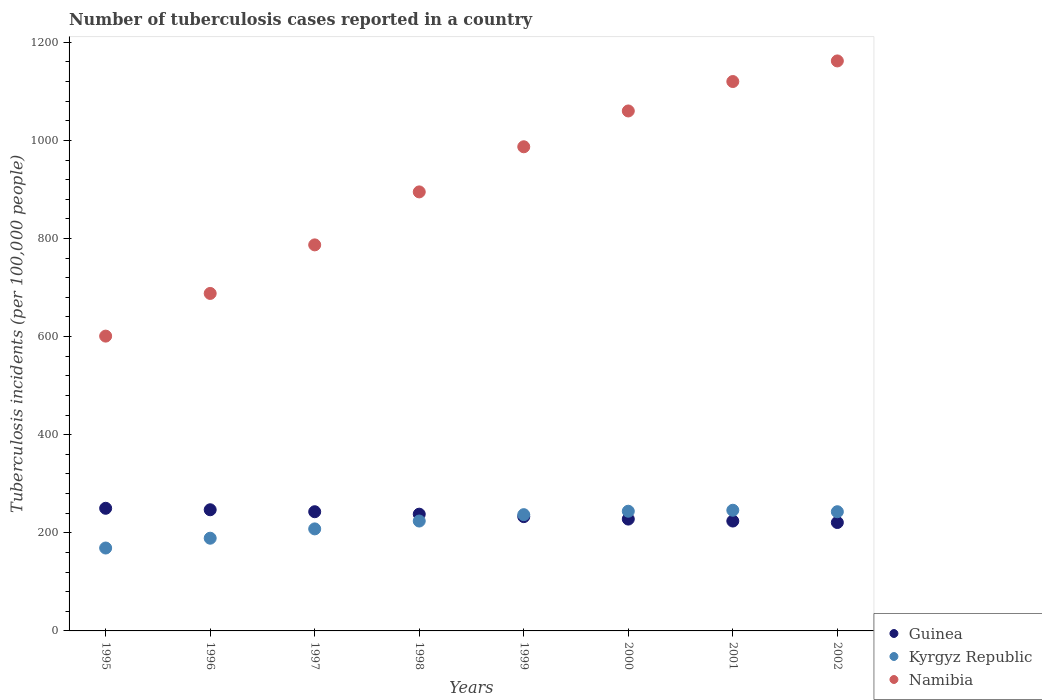How many different coloured dotlines are there?
Make the answer very short. 3. What is the number of tuberculosis cases reported in in Kyrgyz Republic in 2001?
Provide a short and direct response. 246. Across all years, what is the maximum number of tuberculosis cases reported in in Guinea?
Make the answer very short. 250. Across all years, what is the minimum number of tuberculosis cases reported in in Namibia?
Make the answer very short. 601. In which year was the number of tuberculosis cases reported in in Namibia maximum?
Offer a very short reply. 2002. In which year was the number of tuberculosis cases reported in in Namibia minimum?
Keep it short and to the point. 1995. What is the total number of tuberculosis cases reported in in Guinea in the graph?
Your response must be concise. 1884. What is the difference between the number of tuberculosis cases reported in in Namibia in 1997 and that in 2001?
Your answer should be very brief. -333. What is the difference between the number of tuberculosis cases reported in in Guinea in 1998 and the number of tuberculosis cases reported in in Namibia in 1999?
Your response must be concise. -749. What is the average number of tuberculosis cases reported in in Kyrgyz Republic per year?
Provide a short and direct response. 220. In the year 1997, what is the difference between the number of tuberculosis cases reported in in Kyrgyz Republic and number of tuberculosis cases reported in in Guinea?
Give a very brief answer. -35. What is the ratio of the number of tuberculosis cases reported in in Namibia in 2001 to that in 2002?
Your answer should be compact. 0.96. Is the difference between the number of tuberculosis cases reported in in Kyrgyz Republic in 1995 and 2002 greater than the difference between the number of tuberculosis cases reported in in Guinea in 1995 and 2002?
Your answer should be very brief. No. What is the difference between the highest and the lowest number of tuberculosis cases reported in in Kyrgyz Republic?
Provide a short and direct response. 77. In how many years, is the number of tuberculosis cases reported in in Namibia greater than the average number of tuberculosis cases reported in in Namibia taken over all years?
Provide a short and direct response. 4. Does the number of tuberculosis cases reported in in Namibia monotonically increase over the years?
Your response must be concise. Yes. Is the number of tuberculosis cases reported in in Kyrgyz Republic strictly greater than the number of tuberculosis cases reported in in Namibia over the years?
Your answer should be compact. No. How many years are there in the graph?
Provide a succinct answer. 8. What is the difference between two consecutive major ticks on the Y-axis?
Make the answer very short. 200. Are the values on the major ticks of Y-axis written in scientific E-notation?
Your answer should be compact. No. Does the graph contain any zero values?
Ensure brevity in your answer.  No. Where does the legend appear in the graph?
Give a very brief answer. Bottom right. How many legend labels are there?
Provide a short and direct response. 3. How are the legend labels stacked?
Your answer should be compact. Vertical. What is the title of the graph?
Offer a terse response. Number of tuberculosis cases reported in a country. Does "Saudi Arabia" appear as one of the legend labels in the graph?
Your answer should be compact. No. What is the label or title of the X-axis?
Make the answer very short. Years. What is the label or title of the Y-axis?
Keep it short and to the point. Tuberculosis incidents (per 100,0 people). What is the Tuberculosis incidents (per 100,000 people) of Guinea in 1995?
Offer a very short reply. 250. What is the Tuberculosis incidents (per 100,000 people) of Kyrgyz Republic in 1995?
Your answer should be compact. 169. What is the Tuberculosis incidents (per 100,000 people) of Namibia in 1995?
Your answer should be very brief. 601. What is the Tuberculosis incidents (per 100,000 people) of Guinea in 1996?
Keep it short and to the point. 247. What is the Tuberculosis incidents (per 100,000 people) of Kyrgyz Republic in 1996?
Give a very brief answer. 189. What is the Tuberculosis incidents (per 100,000 people) of Namibia in 1996?
Keep it short and to the point. 688. What is the Tuberculosis incidents (per 100,000 people) in Guinea in 1997?
Keep it short and to the point. 243. What is the Tuberculosis incidents (per 100,000 people) of Kyrgyz Republic in 1997?
Your response must be concise. 208. What is the Tuberculosis incidents (per 100,000 people) in Namibia in 1997?
Ensure brevity in your answer.  787. What is the Tuberculosis incidents (per 100,000 people) in Guinea in 1998?
Your response must be concise. 238. What is the Tuberculosis incidents (per 100,000 people) of Kyrgyz Republic in 1998?
Offer a very short reply. 224. What is the Tuberculosis incidents (per 100,000 people) in Namibia in 1998?
Ensure brevity in your answer.  895. What is the Tuberculosis incidents (per 100,000 people) of Guinea in 1999?
Ensure brevity in your answer.  233. What is the Tuberculosis incidents (per 100,000 people) of Kyrgyz Republic in 1999?
Offer a very short reply. 237. What is the Tuberculosis incidents (per 100,000 people) in Namibia in 1999?
Make the answer very short. 987. What is the Tuberculosis incidents (per 100,000 people) in Guinea in 2000?
Ensure brevity in your answer.  228. What is the Tuberculosis incidents (per 100,000 people) of Kyrgyz Republic in 2000?
Provide a succinct answer. 244. What is the Tuberculosis incidents (per 100,000 people) of Namibia in 2000?
Make the answer very short. 1060. What is the Tuberculosis incidents (per 100,000 people) of Guinea in 2001?
Offer a very short reply. 224. What is the Tuberculosis incidents (per 100,000 people) in Kyrgyz Republic in 2001?
Provide a succinct answer. 246. What is the Tuberculosis incidents (per 100,000 people) in Namibia in 2001?
Make the answer very short. 1120. What is the Tuberculosis incidents (per 100,000 people) in Guinea in 2002?
Your answer should be very brief. 221. What is the Tuberculosis incidents (per 100,000 people) in Kyrgyz Republic in 2002?
Your response must be concise. 243. What is the Tuberculosis incidents (per 100,000 people) in Namibia in 2002?
Give a very brief answer. 1162. Across all years, what is the maximum Tuberculosis incidents (per 100,000 people) in Guinea?
Offer a very short reply. 250. Across all years, what is the maximum Tuberculosis incidents (per 100,000 people) of Kyrgyz Republic?
Offer a very short reply. 246. Across all years, what is the maximum Tuberculosis incidents (per 100,000 people) in Namibia?
Ensure brevity in your answer.  1162. Across all years, what is the minimum Tuberculosis incidents (per 100,000 people) of Guinea?
Your answer should be very brief. 221. Across all years, what is the minimum Tuberculosis incidents (per 100,000 people) of Kyrgyz Republic?
Offer a very short reply. 169. Across all years, what is the minimum Tuberculosis incidents (per 100,000 people) of Namibia?
Provide a succinct answer. 601. What is the total Tuberculosis incidents (per 100,000 people) in Guinea in the graph?
Your answer should be compact. 1884. What is the total Tuberculosis incidents (per 100,000 people) in Kyrgyz Republic in the graph?
Provide a short and direct response. 1760. What is the total Tuberculosis incidents (per 100,000 people) in Namibia in the graph?
Keep it short and to the point. 7300. What is the difference between the Tuberculosis incidents (per 100,000 people) of Namibia in 1995 and that in 1996?
Provide a succinct answer. -87. What is the difference between the Tuberculosis incidents (per 100,000 people) of Guinea in 1995 and that in 1997?
Your answer should be compact. 7. What is the difference between the Tuberculosis incidents (per 100,000 people) in Kyrgyz Republic in 1995 and that in 1997?
Provide a succinct answer. -39. What is the difference between the Tuberculosis incidents (per 100,000 people) of Namibia in 1995 and that in 1997?
Your answer should be very brief. -186. What is the difference between the Tuberculosis incidents (per 100,000 people) of Guinea in 1995 and that in 1998?
Your response must be concise. 12. What is the difference between the Tuberculosis incidents (per 100,000 people) of Kyrgyz Republic in 1995 and that in 1998?
Provide a short and direct response. -55. What is the difference between the Tuberculosis incidents (per 100,000 people) of Namibia in 1995 and that in 1998?
Your answer should be compact. -294. What is the difference between the Tuberculosis incidents (per 100,000 people) of Guinea in 1995 and that in 1999?
Ensure brevity in your answer.  17. What is the difference between the Tuberculosis incidents (per 100,000 people) of Kyrgyz Republic in 1995 and that in 1999?
Give a very brief answer. -68. What is the difference between the Tuberculosis incidents (per 100,000 people) of Namibia in 1995 and that in 1999?
Offer a terse response. -386. What is the difference between the Tuberculosis incidents (per 100,000 people) in Kyrgyz Republic in 1995 and that in 2000?
Your response must be concise. -75. What is the difference between the Tuberculosis incidents (per 100,000 people) in Namibia in 1995 and that in 2000?
Keep it short and to the point. -459. What is the difference between the Tuberculosis incidents (per 100,000 people) in Kyrgyz Republic in 1995 and that in 2001?
Make the answer very short. -77. What is the difference between the Tuberculosis incidents (per 100,000 people) of Namibia in 1995 and that in 2001?
Give a very brief answer. -519. What is the difference between the Tuberculosis incidents (per 100,000 people) in Guinea in 1995 and that in 2002?
Offer a terse response. 29. What is the difference between the Tuberculosis incidents (per 100,000 people) in Kyrgyz Republic in 1995 and that in 2002?
Make the answer very short. -74. What is the difference between the Tuberculosis incidents (per 100,000 people) in Namibia in 1995 and that in 2002?
Provide a short and direct response. -561. What is the difference between the Tuberculosis incidents (per 100,000 people) in Namibia in 1996 and that in 1997?
Provide a succinct answer. -99. What is the difference between the Tuberculosis incidents (per 100,000 people) of Guinea in 1996 and that in 1998?
Provide a succinct answer. 9. What is the difference between the Tuberculosis incidents (per 100,000 people) in Kyrgyz Republic in 1996 and that in 1998?
Offer a terse response. -35. What is the difference between the Tuberculosis incidents (per 100,000 people) in Namibia in 1996 and that in 1998?
Your answer should be very brief. -207. What is the difference between the Tuberculosis incidents (per 100,000 people) of Guinea in 1996 and that in 1999?
Your answer should be compact. 14. What is the difference between the Tuberculosis incidents (per 100,000 people) of Kyrgyz Republic in 1996 and that in 1999?
Offer a very short reply. -48. What is the difference between the Tuberculosis incidents (per 100,000 people) in Namibia in 1996 and that in 1999?
Offer a very short reply. -299. What is the difference between the Tuberculosis incidents (per 100,000 people) of Guinea in 1996 and that in 2000?
Offer a terse response. 19. What is the difference between the Tuberculosis incidents (per 100,000 people) of Kyrgyz Republic in 1996 and that in 2000?
Offer a very short reply. -55. What is the difference between the Tuberculosis incidents (per 100,000 people) in Namibia in 1996 and that in 2000?
Make the answer very short. -372. What is the difference between the Tuberculosis incidents (per 100,000 people) in Kyrgyz Republic in 1996 and that in 2001?
Your answer should be very brief. -57. What is the difference between the Tuberculosis incidents (per 100,000 people) in Namibia in 1996 and that in 2001?
Your response must be concise. -432. What is the difference between the Tuberculosis incidents (per 100,000 people) of Kyrgyz Republic in 1996 and that in 2002?
Offer a very short reply. -54. What is the difference between the Tuberculosis incidents (per 100,000 people) of Namibia in 1996 and that in 2002?
Offer a terse response. -474. What is the difference between the Tuberculosis incidents (per 100,000 people) in Kyrgyz Republic in 1997 and that in 1998?
Your answer should be very brief. -16. What is the difference between the Tuberculosis incidents (per 100,000 people) in Namibia in 1997 and that in 1998?
Give a very brief answer. -108. What is the difference between the Tuberculosis incidents (per 100,000 people) in Guinea in 1997 and that in 1999?
Give a very brief answer. 10. What is the difference between the Tuberculosis incidents (per 100,000 people) in Kyrgyz Republic in 1997 and that in 1999?
Offer a terse response. -29. What is the difference between the Tuberculosis incidents (per 100,000 people) of Namibia in 1997 and that in 1999?
Your response must be concise. -200. What is the difference between the Tuberculosis incidents (per 100,000 people) of Guinea in 1997 and that in 2000?
Keep it short and to the point. 15. What is the difference between the Tuberculosis incidents (per 100,000 people) in Kyrgyz Republic in 1997 and that in 2000?
Offer a very short reply. -36. What is the difference between the Tuberculosis incidents (per 100,000 people) in Namibia in 1997 and that in 2000?
Offer a terse response. -273. What is the difference between the Tuberculosis incidents (per 100,000 people) of Guinea in 1997 and that in 2001?
Make the answer very short. 19. What is the difference between the Tuberculosis incidents (per 100,000 people) of Kyrgyz Republic in 1997 and that in 2001?
Provide a succinct answer. -38. What is the difference between the Tuberculosis incidents (per 100,000 people) of Namibia in 1997 and that in 2001?
Keep it short and to the point. -333. What is the difference between the Tuberculosis incidents (per 100,000 people) in Guinea in 1997 and that in 2002?
Provide a succinct answer. 22. What is the difference between the Tuberculosis incidents (per 100,000 people) of Kyrgyz Republic in 1997 and that in 2002?
Provide a succinct answer. -35. What is the difference between the Tuberculosis incidents (per 100,000 people) of Namibia in 1997 and that in 2002?
Your answer should be compact. -375. What is the difference between the Tuberculosis incidents (per 100,000 people) of Guinea in 1998 and that in 1999?
Your answer should be compact. 5. What is the difference between the Tuberculosis incidents (per 100,000 people) in Namibia in 1998 and that in 1999?
Your answer should be very brief. -92. What is the difference between the Tuberculosis incidents (per 100,000 people) of Guinea in 1998 and that in 2000?
Keep it short and to the point. 10. What is the difference between the Tuberculosis incidents (per 100,000 people) of Namibia in 1998 and that in 2000?
Provide a short and direct response. -165. What is the difference between the Tuberculosis incidents (per 100,000 people) in Kyrgyz Republic in 1998 and that in 2001?
Provide a succinct answer. -22. What is the difference between the Tuberculosis incidents (per 100,000 people) in Namibia in 1998 and that in 2001?
Offer a terse response. -225. What is the difference between the Tuberculosis incidents (per 100,000 people) in Guinea in 1998 and that in 2002?
Ensure brevity in your answer.  17. What is the difference between the Tuberculosis incidents (per 100,000 people) in Kyrgyz Republic in 1998 and that in 2002?
Make the answer very short. -19. What is the difference between the Tuberculosis incidents (per 100,000 people) in Namibia in 1998 and that in 2002?
Ensure brevity in your answer.  -267. What is the difference between the Tuberculosis incidents (per 100,000 people) of Namibia in 1999 and that in 2000?
Provide a succinct answer. -73. What is the difference between the Tuberculosis incidents (per 100,000 people) in Guinea in 1999 and that in 2001?
Your response must be concise. 9. What is the difference between the Tuberculosis incidents (per 100,000 people) in Kyrgyz Republic in 1999 and that in 2001?
Make the answer very short. -9. What is the difference between the Tuberculosis incidents (per 100,000 people) in Namibia in 1999 and that in 2001?
Make the answer very short. -133. What is the difference between the Tuberculosis incidents (per 100,000 people) of Guinea in 1999 and that in 2002?
Keep it short and to the point. 12. What is the difference between the Tuberculosis incidents (per 100,000 people) of Namibia in 1999 and that in 2002?
Ensure brevity in your answer.  -175. What is the difference between the Tuberculosis incidents (per 100,000 people) in Kyrgyz Republic in 2000 and that in 2001?
Ensure brevity in your answer.  -2. What is the difference between the Tuberculosis incidents (per 100,000 people) in Namibia in 2000 and that in 2001?
Your answer should be compact. -60. What is the difference between the Tuberculosis incidents (per 100,000 people) of Guinea in 2000 and that in 2002?
Ensure brevity in your answer.  7. What is the difference between the Tuberculosis incidents (per 100,000 people) in Kyrgyz Republic in 2000 and that in 2002?
Your answer should be compact. 1. What is the difference between the Tuberculosis incidents (per 100,000 people) in Namibia in 2000 and that in 2002?
Provide a succinct answer. -102. What is the difference between the Tuberculosis incidents (per 100,000 people) in Guinea in 2001 and that in 2002?
Your answer should be compact. 3. What is the difference between the Tuberculosis incidents (per 100,000 people) in Namibia in 2001 and that in 2002?
Your response must be concise. -42. What is the difference between the Tuberculosis incidents (per 100,000 people) in Guinea in 1995 and the Tuberculosis incidents (per 100,000 people) in Namibia in 1996?
Ensure brevity in your answer.  -438. What is the difference between the Tuberculosis incidents (per 100,000 people) of Kyrgyz Republic in 1995 and the Tuberculosis incidents (per 100,000 people) of Namibia in 1996?
Provide a succinct answer. -519. What is the difference between the Tuberculosis incidents (per 100,000 people) of Guinea in 1995 and the Tuberculosis incidents (per 100,000 people) of Kyrgyz Republic in 1997?
Offer a terse response. 42. What is the difference between the Tuberculosis incidents (per 100,000 people) of Guinea in 1995 and the Tuberculosis incidents (per 100,000 people) of Namibia in 1997?
Offer a terse response. -537. What is the difference between the Tuberculosis incidents (per 100,000 people) of Kyrgyz Republic in 1995 and the Tuberculosis incidents (per 100,000 people) of Namibia in 1997?
Your answer should be compact. -618. What is the difference between the Tuberculosis incidents (per 100,000 people) of Guinea in 1995 and the Tuberculosis incidents (per 100,000 people) of Namibia in 1998?
Provide a short and direct response. -645. What is the difference between the Tuberculosis incidents (per 100,000 people) in Kyrgyz Republic in 1995 and the Tuberculosis incidents (per 100,000 people) in Namibia in 1998?
Give a very brief answer. -726. What is the difference between the Tuberculosis incidents (per 100,000 people) in Guinea in 1995 and the Tuberculosis incidents (per 100,000 people) in Kyrgyz Republic in 1999?
Give a very brief answer. 13. What is the difference between the Tuberculosis incidents (per 100,000 people) in Guinea in 1995 and the Tuberculosis incidents (per 100,000 people) in Namibia in 1999?
Keep it short and to the point. -737. What is the difference between the Tuberculosis incidents (per 100,000 people) in Kyrgyz Republic in 1995 and the Tuberculosis incidents (per 100,000 people) in Namibia in 1999?
Provide a succinct answer. -818. What is the difference between the Tuberculosis incidents (per 100,000 people) of Guinea in 1995 and the Tuberculosis incidents (per 100,000 people) of Namibia in 2000?
Your answer should be compact. -810. What is the difference between the Tuberculosis incidents (per 100,000 people) of Kyrgyz Republic in 1995 and the Tuberculosis incidents (per 100,000 people) of Namibia in 2000?
Your answer should be very brief. -891. What is the difference between the Tuberculosis incidents (per 100,000 people) of Guinea in 1995 and the Tuberculosis incidents (per 100,000 people) of Namibia in 2001?
Ensure brevity in your answer.  -870. What is the difference between the Tuberculosis incidents (per 100,000 people) of Kyrgyz Republic in 1995 and the Tuberculosis incidents (per 100,000 people) of Namibia in 2001?
Your answer should be compact. -951. What is the difference between the Tuberculosis incidents (per 100,000 people) of Guinea in 1995 and the Tuberculosis incidents (per 100,000 people) of Kyrgyz Republic in 2002?
Your answer should be very brief. 7. What is the difference between the Tuberculosis incidents (per 100,000 people) of Guinea in 1995 and the Tuberculosis incidents (per 100,000 people) of Namibia in 2002?
Provide a succinct answer. -912. What is the difference between the Tuberculosis incidents (per 100,000 people) of Kyrgyz Republic in 1995 and the Tuberculosis incidents (per 100,000 people) of Namibia in 2002?
Your response must be concise. -993. What is the difference between the Tuberculosis incidents (per 100,000 people) of Guinea in 1996 and the Tuberculosis incidents (per 100,000 people) of Namibia in 1997?
Make the answer very short. -540. What is the difference between the Tuberculosis incidents (per 100,000 people) of Kyrgyz Republic in 1996 and the Tuberculosis incidents (per 100,000 people) of Namibia in 1997?
Keep it short and to the point. -598. What is the difference between the Tuberculosis incidents (per 100,000 people) of Guinea in 1996 and the Tuberculosis incidents (per 100,000 people) of Kyrgyz Republic in 1998?
Make the answer very short. 23. What is the difference between the Tuberculosis incidents (per 100,000 people) in Guinea in 1996 and the Tuberculosis incidents (per 100,000 people) in Namibia in 1998?
Your answer should be very brief. -648. What is the difference between the Tuberculosis incidents (per 100,000 people) in Kyrgyz Republic in 1996 and the Tuberculosis incidents (per 100,000 people) in Namibia in 1998?
Your answer should be compact. -706. What is the difference between the Tuberculosis incidents (per 100,000 people) in Guinea in 1996 and the Tuberculosis incidents (per 100,000 people) in Kyrgyz Republic in 1999?
Your answer should be compact. 10. What is the difference between the Tuberculosis incidents (per 100,000 people) of Guinea in 1996 and the Tuberculosis incidents (per 100,000 people) of Namibia in 1999?
Provide a succinct answer. -740. What is the difference between the Tuberculosis incidents (per 100,000 people) of Kyrgyz Republic in 1996 and the Tuberculosis incidents (per 100,000 people) of Namibia in 1999?
Make the answer very short. -798. What is the difference between the Tuberculosis incidents (per 100,000 people) in Guinea in 1996 and the Tuberculosis incidents (per 100,000 people) in Namibia in 2000?
Offer a terse response. -813. What is the difference between the Tuberculosis incidents (per 100,000 people) in Kyrgyz Republic in 1996 and the Tuberculosis incidents (per 100,000 people) in Namibia in 2000?
Give a very brief answer. -871. What is the difference between the Tuberculosis incidents (per 100,000 people) of Guinea in 1996 and the Tuberculosis incidents (per 100,000 people) of Kyrgyz Republic in 2001?
Your response must be concise. 1. What is the difference between the Tuberculosis incidents (per 100,000 people) of Guinea in 1996 and the Tuberculosis incidents (per 100,000 people) of Namibia in 2001?
Offer a very short reply. -873. What is the difference between the Tuberculosis incidents (per 100,000 people) in Kyrgyz Republic in 1996 and the Tuberculosis incidents (per 100,000 people) in Namibia in 2001?
Offer a terse response. -931. What is the difference between the Tuberculosis incidents (per 100,000 people) of Guinea in 1996 and the Tuberculosis incidents (per 100,000 people) of Kyrgyz Republic in 2002?
Ensure brevity in your answer.  4. What is the difference between the Tuberculosis incidents (per 100,000 people) in Guinea in 1996 and the Tuberculosis incidents (per 100,000 people) in Namibia in 2002?
Your response must be concise. -915. What is the difference between the Tuberculosis incidents (per 100,000 people) of Kyrgyz Republic in 1996 and the Tuberculosis incidents (per 100,000 people) of Namibia in 2002?
Ensure brevity in your answer.  -973. What is the difference between the Tuberculosis incidents (per 100,000 people) of Guinea in 1997 and the Tuberculosis incidents (per 100,000 people) of Namibia in 1998?
Give a very brief answer. -652. What is the difference between the Tuberculosis incidents (per 100,000 people) in Kyrgyz Republic in 1997 and the Tuberculosis incidents (per 100,000 people) in Namibia in 1998?
Offer a terse response. -687. What is the difference between the Tuberculosis incidents (per 100,000 people) of Guinea in 1997 and the Tuberculosis incidents (per 100,000 people) of Kyrgyz Republic in 1999?
Keep it short and to the point. 6. What is the difference between the Tuberculosis incidents (per 100,000 people) of Guinea in 1997 and the Tuberculosis incidents (per 100,000 people) of Namibia in 1999?
Provide a succinct answer. -744. What is the difference between the Tuberculosis incidents (per 100,000 people) of Kyrgyz Republic in 1997 and the Tuberculosis incidents (per 100,000 people) of Namibia in 1999?
Keep it short and to the point. -779. What is the difference between the Tuberculosis incidents (per 100,000 people) of Guinea in 1997 and the Tuberculosis incidents (per 100,000 people) of Namibia in 2000?
Provide a short and direct response. -817. What is the difference between the Tuberculosis incidents (per 100,000 people) in Kyrgyz Republic in 1997 and the Tuberculosis incidents (per 100,000 people) in Namibia in 2000?
Give a very brief answer. -852. What is the difference between the Tuberculosis incidents (per 100,000 people) in Guinea in 1997 and the Tuberculosis incidents (per 100,000 people) in Kyrgyz Republic in 2001?
Ensure brevity in your answer.  -3. What is the difference between the Tuberculosis incidents (per 100,000 people) in Guinea in 1997 and the Tuberculosis incidents (per 100,000 people) in Namibia in 2001?
Your answer should be very brief. -877. What is the difference between the Tuberculosis incidents (per 100,000 people) of Kyrgyz Republic in 1997 and the Tuberculosis incidents (per 100,000 people) of Namibia in 2001?
Provide a succinct answer. -912. What is the difference between the Tuberculosis incidents (per 100,000 people) of Guinea in 1997 and the Tuberculosis incidents (per 100,000 people) of Kyrgyz Republic in 2002?
Offer a very short reply. 0. What is the difference between the Tuberculosis incidents (per 100,000 people) of Guinea in 1997 and the Tuberculosis incidents (per 100,000 people) of Namibia in 2002?
Offer a very short reply. -919. What is the difference between the Tuberculosis incidents (per 100,000 people) of Kyrgyz Republic in 1997 and the Tuberculosis incidents (per 100,000 people) of Namibia in 2002?
Your answer should be very brief. -954. What is the difference between the Tuberculosis incidents (per 100,000 people) of Guinea in 1998 and the Tuberculosis incidents (per 100,000 people) of Kyrgyz Republic in 1999?
Your answer should be compact. 1. What is the difference between the Tuberculosis incidents (per 100,000 people) of Guinea in 1998 and the Tuberculosis incidents (per 100,000 people) of Namibia in 1999?
Offer a very short reply. -749. What is the difference between the Tuberculosis incidents (per 100,000 people) in Kyrgyz Republic in 1998 and the Tuberculosis incidents (per 100,000 people) in Namibia in 1999?
Provide a short and direct response. -763. What is the difference between the Tuberculosis incidents (per 100,000 people) of Guinea in 1998 and the Tuberculosis incidents (per 100,000 people) of Namibia in 2000?
Your answer should be very brief. -822. What is the difference between the Tuberculosis incidents (per 100,000 people) in Kyrgyz Republic in 1998 and the Tuberculosis incidents (per 100,000 people) in Namibia in 2000?
Offer a very short reply. -836. What is the difference between the Tuberculosis incidents (per 100,000 people) in Guinea in 1998 and the Tuberculosis incidents (per 100,000 people) in Kyrgyz Republic in 2001?
Provide a succinct answer. -8. What is the difference between the Tuberculosis incidents (per 100,000 people) in Guinea in 1998 and the Tuberculosis incidents (per 100,000 people) in Namibia in 2001?
Make the answer very short. -882. What is the difference between the Tuberculosis incidents (per 100,000 people) in Kyrgyz Republic in 1998 and the Tuberculosis incidents (per 100,000 people) in Namibia in 2001?
Ensure brevity in your answer.  -896. What is the difference between the Tuberculosis incidents (per 100,000 people) in Guinea in 1998 and the Tuberculosis incidents (per 100,000 people) in Kyrgyz Republic in 2002?
Your answer should be compact. -5. What is the difference between the Tuberculosis incidents (per 100,000 people) in Guinea in 1998 and the Tuberculosis incidents (per 100,000 people) in Namibia in 2002?
Make the answer very short. -924. What is the difference between the Tuberculosis incidents (per 100,000 people) in Kyrgyz Republic in 1998 and the Tuberculosis incidents (per 100,000 people) in Namibia in 2002?
Your answer should be compact. -938. What is the difference between the Tuberculosis incidents (per 100,000 people) in Guinea in 1999 and the Tuberculosis incidents (per 100,000 people) in Kyrgyz Republic in 2000?
Offer a very short reply. -11. What is the difference between the Tuberculosis incidents (per 100,000 people) in Guinea in 1999 and the Tuberculosis incidents (per 100,000 people) in Namibia in 2000?
Give a very brief answer. -827. What is the difference between the Tuberculosis incidents (per 100,000 people) in Kyrgyz Republic in 1999 and the Tuberculosis incidents (per 100,000 people) in Namibia in 2000?
Offer a terse response. -823. What is the difference between the Tuberculosis incidents (per 100,000 people) of Guinea in 1999 and the Tuberculosis incidents (per 100,000 people) of Namibia in 2001?
Your response must be concise. -887. What is the difference between the Tuberculosis incidents (per 100,000 people) of Kyrgyz Republic in 1999 and the Tuberculosis incidents (per 100,000 people) of Namibia in 2001?
Give a very brief answer. -883. What is the difference between the Tuberculosis incidents (per 100,000 people) of Guinea in 1999 and the Tuberculosis incidents (per 100,000 people) of Namibia in 2002?
Keep it short and to the point. -929. What is the difference between the Tuberculosis incidents (per 100,000 people) of Kyrgyz Republic in 1999 and the Tuberculosis incidents (per 100,000 people) of Namibia in 2002?
Provide a short and direct response. -925. What is the difference between the Tuberculosis incidents (per 100,000 people) in Guinea in 2000 and the Tuberculosis incidents (per 100,000 people) in Namibia in 2001?
Offer a very short reply. -892. What is the difference between the Tuberculosis incidents (per 100,000 people) of Kyrgyz Republic in 2000 and the Tuberculosis incidents (per 100,000 people) of Namibia in 2001?
Provide a short and direct response. -876. What is the difference between the Tuberculosis incidents (per 100,000 people) in Guinea in 2000 and the Tuberculosis incidents (per 100,000 people) in Namibia in 2002?
Your answer should be very brief. -934. What is the difference between the Tuberculosis incidents (per 100,000 people) of Kyrgyz Republic in 2000 and the Tuberculosis incidents (per 100,000 people) of Namibia in 2002?
Your answer should be very brief. -918. What is the difference between the Tuberculosis incidents (per 100,000 people) of Guinea in 2001 and the Tuberculosis incidents (per 100,000 people) of Kyrgyz Republic in 2002?
Your response must be concise. -19. What is the difference between the Tuberculosis incidents (per 100,000 people) in Guinea in 2001 and the Tuberculosis incidents (per 100,000 people) in Namibia in 2002?
Your response must be concise. -938. What is the difference between the Tuberculosis incidents (per 100,000 people) of Kyrgyz Republic in 2001 and the Tuberculosis incidents (per 100,000 people) of Namibia in 2002?
Provide a short and direct response. -916. What is the average Tuberculosis incidents (per 100,000 people) of Guinea per year?
Offer a very short reply. 235.5. What is the average Tuberculosis incidents (per 100,000 people) of Kyrgyz Republic per year?
Offer a terse response. 220. What is the average Tuberculosis incidents (per 100,000 people) of Namibia per year?
Your response must be concise. 912.5. In the year 1995, what is the difference between the Tuberculosis incidents (per 100,000 people) of Guinea and Tuberculosis incidents (per 100,000 people) of Namibia?
Offer a terse response. -351. In the year 1995, what is the difference between the Tuberculosis incidents (per 100,000 people) in Kyrgyz Republic and Tuberculosis incidents (per 100,000 people) in Namibia?
Your answer should be very brief. -432. In the year 1996, what is the difference between the Tuberculosis incidents (per 100,000 people) in Guinea and Tuberculosis incidents (per 100,000 people) in Kyrgyz Republic?
Your answer should be compact. 58. In the year 1996, what is the difference between the Tuberculosis incidents (per 100,000 people) of Guinea and Tuberculosis incidents (per 100,000 people) of Namibia?
Offer a terse response. -441. In the year 1996, what is the difference between the Tuberculosis incidents (per 100,000 people) in Kyrgyz Republic and Tuberculosis incidents (per 100,000 people) in Namibia?
Your answer should be very brief. -499. In the year 1997, what is the difference between the Tuberculosis incidents (per 100,000 people) in Guinea and Tuberculosis incidents (per 100,000 people) in Namibia?
Ensure brevity in your answer.  -544. In the year 1997, what is the difference between the Tuberculosis incidents (per 100,000 people) in Kyrgyz Republic and Tuberculosis incidents (per 100,000 people) in Namibia?
Provide a short and direct response. -579. In the year 1998, what is the difference between the Tuberculosis incidents (per 100,000 people) in Guinea and Tuberculosis incidents (per 100,000 people) in Namibia?
Keep it short and to the point. -657. In the year 1998, what is the difference between the Tuberculosis incidents (per 100,000 people) in Kyrgyz Republic and Tuberculosis incidents (per 100,000 people) in Namibia?
Provide a succinct answer. -671. In the year 1999, what is the difference between the Tuberculosis incidents (per 100,000 people) in Guinea and Tuberculosis incidents (per 100,000 people) in Namibia?
Provide a succinct answer. -754. In the year 1999, what is the difference between the Tuberculosis incidents (per 100,000 people) of Kyrgyz Republic and Tuberculosis incidents (per 100,000 people) of Namibia?
Keep it short and to the point. -750. In the year 2000, what is the difference between the Tuberculosis incidents (per 100,000 people) in Guinea and Tuberculosis incidents (per 100,000 people) in Namibia?
Give a very brief answer. -832. In the year 2000, what is the difference between the Tuberculosis incidents (per 100,000 people) of Kyrgyz Republic and Tuberculosis incidents (per 100,000 people) of Namibia?
Offer a terse response. -816. In the year 2001, what is the difference between the Tuberculosis incidents (per 100,000 people) of Guinea and Tuberculosis incidents (per 100,000 people) of Namibia?
Offer a very short reply. -896. In the year 2001, what is the difference between the Tuberculosis incidents (per 100,000 people) in Kyrgyz Republic and Tuberculosis incidents (per 100,000 people) in Namibia?
Your answer should be compact. -874. In the year 2002, what is the difference between the Tuberculosis incidents (per 100,000 people) in Guinea and Tuberculosis incidents (per 100,000 people) in Namibia?
Your answer should be very brief. -941. In the year 2002, what is the difference between the Tuberculosis incidents (per 100,000 people) in Kyrgyz Republic and Tuberculosis incidents (per 100,000 people) in Namibia?
Your answer should be compact. -919. What is the ratio of the Tuberculosis incidents (per 100,000 people) in Guinea in 1995 to that in 1996?
Make the answer very short. 1.01. What is the ratio of the Tuberculosis incidents (per 100,000 people) of Kyrgyz Republic in 1995 to that in 1996?
Make the answer very short. 0.89. What is the ratio of the Tuberculosis incidents (per 100,000 people) of Namibia in 1995 to that in 1996?
Your response must be concise. 0.87. What is the ratio of the Tuberculosis incidents (per 100,000 people) of Guinea in 1995 to that in 1997?
Provide a short and direct response. 1.03. What is the ratio of the Tuberculosis incidents (per 100,000 people) in Kyrgyz Republic in 1995 to that in 1997?
Your answer should be very brief. 0.81. What is the ratio of the Tuberculosis incidents (per 100,000 people) in Namibia in 1995 to that in 1997?
Provide a succinct answer. 0.76. What is the ratio of the Tuberculosis incidents (per 100,000 people) in Guinea in 1995 to that in 1998?
Make the answer very short. 1.05. What is the ratio of the Tuberculosis incidents (per 100,000 people) in Kyrgyz Republic in 1995 to that in 1998?
Your answer should be compact. 0.75. What is the ratio of the Tuberculosis incidents (per 100,000 people) in Namibia in 1995 to that in 1998?
Offer a terse response. 0.67. What is the ratio of the Tuberculosis incidents (per 100,000 people) of Guinea in 1995 to that in 1999?
Offer a very short reply. 1.07. What is the ratio of the Tuberculosis incidents (per 100,000 people) in Kyrgyz Republic in 1995 to that in 1999?
Your response must be concise. 0.71. What is the ratio of the Tuberculosis incidents (per 100,000 people) of Namibia in 1995 to that in 1999?
Ensure brevity in your answer.  0.61. What is the ratio of the Tuberculosis incidents (per 100,000 people) of Guinea in 1995 to that in 2000?
Keep it short and to the point. 1.1. What is the ratio of the Tuberculosis incidents (per 100,000 people) of Kyrgyz Republic in 1995 to that in 2000?
Give a very brief answer. 0.69. What is the ratio of the Tuberculosis incidents (per 100,000 people) of Namibia in 1995 to that in 2000?
Provide a short and direct response. 0.57. What is the ratio of the Tuberculosis incidents (per 100,000 people) of Guinea in 1995 to that in 2001?
Keep it short and to the point. 1.12. What is the ratio of the Tuberculosis incidents (per 100,000 people) of Kyrgyz Republic in 1995 to that in 2001?
Offer a very short reply. 0.69. What is the ratio of the Tuberculosis incidents (per 100,000 people) of Namibia in 1995 to that in 2001?
Provide a succinct answer. 0.54. What is the ratio of the Tuberculosis incidents (per 100,000 people) in Guinea in 1995 to that in 2002?
Provide a succinct answer. 1.13. What is the ratio of the Tuberculosis incidents (per 100,000 people) of Kyrgyz Republic in 1995 to that in 2002?
Ensure brevity in your answer.  0.7. What is the ratio of the Tuberculosis incidents (per 100,000 people) in Namibia in 1995 to that in 2002?
Provide a short and direct response. 0.52. What is the ratio of the Tuberculosis incidents (per 100,000 people) in Guinea in 1996 to that in 1997?
Provide a succinct answer. 1.02. What is the ratio of the Tuberculosis incidents (per 100,000 people) of Kyrgyz Republic in 1996 to that in 1997?
Keep it short and to the point. 0.91. What is the ratio of the Tuberculosis incidents (per 100,000 people) in Namibia in 1996 to that in 1997?
Provide a short and direct response. 0.87. What is the ratio of the Tuberculosis incidents (per 100,000 people) of Guinea in 1996 to that in 1998?
Make the answer very short. 1.04. What is the ratio of the Tuberculosis incidents (per 100,000 people) in Kyrgyz Republic in 1996 to that in 1998?
Your response must be concise. 0.84. What is the ratio of the Tuberculosis incidents (per 100,000 people) of Namibia in 1996 to that in 1998?
Your response must be concise. 0.77. What is the ratio of the Tuberculosis incidents (per 100,000 people) of Guinea in 1996 to that in 1999?
Provide a short and direct response. 1.06. What is the ratio of the Tuberculosis incidents (per 100,000 people) in Kyrgyz Republic in 1996 to that in 1999?
Give a very brief answer. 0.8. What is the ratio of the Tuberculosis incidents (per 100,000 people) in Namibia in 1996 to that in 1999?
Your answer should be very brief. 0.7. What is the ratio of the Tuberculosis incidents (per 100,000 people) in Guinea in 1996 to that in 2000?
Keep it short and to the point. 1.08. What is the ratio of the Tuberculosis incidents (per 100,000 people) of Kyrgyz Republic in 1996 to that in 2000?
Ensure brevity in your answer.  0.77. What is the ratio of the Tuberculosis incidents (per 100,000 people) in Namibia in 1996 to that in 2000?
Offer a terse response. 0.65. What is the ratio of the Tuberculosis incidents (per 100,000 people) of Guinea in 1996 to that in 2001?
Your answer should be very brief. 1.1. What is the ratio of the Tuberculosis incidents (per 100,000 people) in Kyrgyz Republic in 1996 to that in 2001?
Ensure brevity in your answer.  0.77. What is the ratio of the Tuberculosis incidents (per 100,000 people) of Namibia in 1996 to that in 2001?
Ensure brevity in your answer.  0.61. What is the ratio of the Tuberculosis incidents (per 100,000 people) of Guinea in 1996 to that in 2002?
Make the answer very short. 1.12. What is the ratio of the Tuberculosis incidents (per 100,000 people) of Kyrgyz Republic in 1996 to that in 2002?
Provide a short and direct response. 0.78. What is the ratio of the Tuberculosis incidents (per 100,000 people) of Namibia in 1996 to that in 2002?
Give a very brief answer. 0.59. What is the ratio of the Tuberculosis incidents (per 100,000 people) of Guinea in 1997 to that in 1998?
Your answer should be compact. 1.02. What is the ratio of the Tuberculosis incidents (per 100,000 people) of Kyrgyz Republic in 1997 to that in 1998?
Your response must be concise. 0.93. What is the ratio of the Tuberculosis incidents (per 100,000 people) in Namibia in 1997 to that in 1998?
Offer a very short reply. 0.88. What is the ratio of the Tuberculosis incidents (per 100,000 people) of Guinea in 1997 to that in 1999?
Your answer should be compact. 1.04. What is the ratio of the Tuberculosis incidents (per 100,000 people) in Kyrgyz Republic in 1997 to that in 1999?
Make the answer very short. 0.88. What is the ratio of the Tuberculosis incidents (per 100,000 people) in Namibia in 1997 to that in 1999?
Your answer should be compact. 0.8. What is the ratio of the Tuberculosis incidents (per 100,000 people) of Guinea in 1997 to that in 2000?
Provide a succinct answer. 1.07. What is the ratio of the Tuberculosis incidents (per 100,000 people) in Kyrgyz Republic in 1997 to that in 2000?
Offer a terse response. 0.85. What is the ratio of the Tuberculosis incidents (per 100,000 people) of Namibia in 1997 to that in 2000?
Your response must be concise. 0.74. What is the ratio of the Tuberculosis incidents (per 100,000 people) in Guinea in 1997 to that in 2001?
Give a very brief answer. 1.08. What is the ratio of the Tuberculosis incidents (per 100,000 people) of Kyrgyz Republic in 1997 to that in 2001?
Make the answer very short. 0.85. What is the ratio of the Tuberculosis incidents (per 100,000 people) of Namibia in 1997 to that in 2001?
Keep it short and to the point. 0.7. What is the ratio of the Tuberculosis incidents (per 100,000 people) in Guinea in 1997 to that in 2002?
Make the answer very short. 1.1. What is the ratio of the Tuberculosis incidents (per 100,000 people) of Kyrgyz Republic in 1997 to that in 2002?
Your answer should be compact. 0.86. What is the ratio of the Tuberculosis incidents (per 100,000 people) of Namibia in 1997 to that in 2002?
Offer a terse response. 0.68. What is the ratio of the Tuberculosis incidents (per 100,000 people) of Guinea in 1998 to that in 1999?
Keep it short and to the point. 1.02. What is the ratio of the Tuberculosis incidents (per 100,000 people) in Kyrgyz Republic in 1998 to that in 1999?
Offer a very short reply. 0.95. What is the ratio of the Tuberculosis incidents (per 100,000 people) of Namibia in 1998 to that in 1999?
Your answer should be compact. 0.91. What is the ratio of the Tuberculosis incidents (per 100,000 people) of Guinea in 1998 to that in 2000?
Your answer should be compact. 1.04. What is the ratio of the Tuberculosis incidents (per 100,000 people) in Kyrgyz Republic in 1998 to that in 2000?
Provide a succinct answer. 0.92. What is the ratio of the Tuberculosis incidents (per 100,000 people) in Namibia in 1998 to that in 2000?
Provide a short and direct response. 0.84. What is the ratio of the Tuberculosis incidents (per 100,000 people) in Guinea in 1998 to that in 2001?
Your answer should be compact. 1.06. What is the ratio of the Tuberculosis incidents (per 100,000 people) in Kyrgyz Republic in 1998 to that in 2001?
Offer a very short reply. 0.91. What is the ratio of the Tuberculosis incidents (per 100,000 people) in Namibia in 1998 to that in 2001?
Your response must be concise. 0.8. What is the ratio of the Tuberculosis incidents (per 100,000 people) of Kyrgyz Republic in 1998 to that in 2002?
Make the answer very short. 0.92. What is the ratio of the Tuberculosis incidents (per 100,000 people) of Namibia in 1998 to that in 2002?
Your response must be concise. 0.77. What is the ratio of the Tuberculosis incidents (per 100,000 people) of Guinea in 1999 to that in 2000?
Keep it short and to the point. 1.02. What is the ratio of the Tuberculosis incidents (per 100,000 people) in Kyrgyz Republic in 1999 to that in 2000?
Keep it short and to the point. 0.97. What is the ratio of the Tuberculosis incidents (per 100,000 people) of Namibia in 1999 to that in 2000?
Your response must be concise. 0.93. What is the ratio of the Tuberculosis incidents (per 100,000 people) of Guinea in 1999 to that in 2001?
Give a very brief answer. 1.04. What is the ratio of the Tuberculosis incidents (per 100,000 people) in Kyrgyz Republic in 1999 to that in 2001?
Provide a short and direct response. 0.96. What is the ratio of the Tuberculosis incidents (per 100,000 people) in Namibia in 1999 to that in 2001?
Provide a succinct answer. 0.88. What is the ratio of the Tuberculosis incidents (per 100,000 people) of Guinea in 1999 to that in 2002?
Make the answer very short. 1.05. What is the ratio of the Tuberculosis incidents (per 100,000 people) of Kyrgyz Republic in 1999 to that in 2002?
Offer a very short reply. 0.98. What is the ratio of the Tuberculosis incidents (per 100,000 people) in Namibia in 1999 to that in 2002?
Provide a short and direct response. 0.85. What is the ratio of the Tuberculosis incidents (per 100,000 people) in Guinea in 2000 to that in 2001?
Ensure brevity in your answer.  1.02. What is the ratio of the Tuberculosis incidents (per 100,000 people) of Kyrgyz Republic in 2000 to that in 2001?
Provide a succinct answer. 0.99. What is the ratio of the Tuberculosis incidents (per 100,000 people) of Namibia in 2000 to that in 2001?
Make the answer very short. 0.95. What is the ratio of the Tuberculosis incidents (per 100,000 people) in Guinea in 2000 to that in 2002?
Your answer should be very brief. 1.03. What is the ratio of the Tuberculosis incidents (per 100,000 people) of Namibia in 2000 to that in 2002?
Provide a short and direct response. 0.91. What is the ratio of the Tuberculosis incidents (per 100,000 people) of Guinea in 2001 to that in 2002?
Your answer should be very brief. 1.01. What is the ratio of the Tuberculosis incidents (per 100,000 people) in Kyrgyz Republic in 2001 to that in 2002?
Give a very brief answer. 1.01. What is the ratio of the Tuberculosis incidents (per 100,000 people) in Namibia in 2001 to that in 2002?
Make the answer very short. 0.96. What is the difference between the highest and the lowest Tuberculosis incidents (per 100,000 people) of Namibia?
Your answer should be compact. 561. 